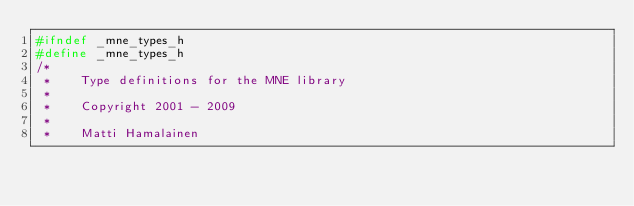<code> <loc_0><loc_0><loc_500><loc_500><_C_>#ifndef _mne_types_h
#define _mne_types_h
/*
 *    Type definitions for the MNE library
 *
 *    Copyright 2001 - 2009
 *
 *    Matti Hamalainen</code> 